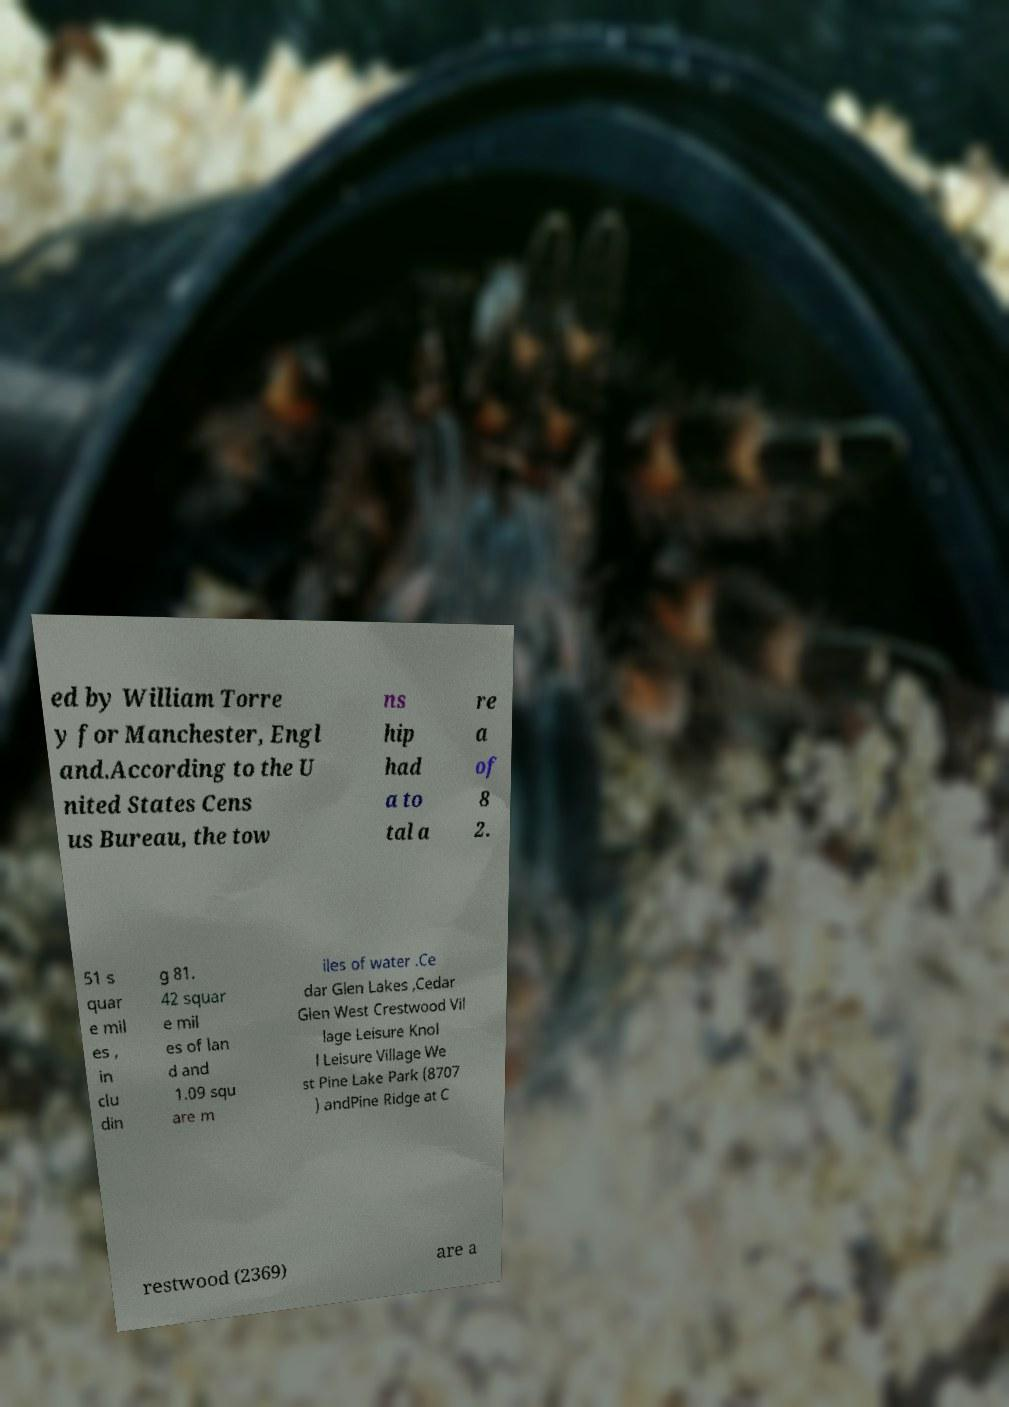I need the written content from this picture converted into text. Can you do that? ed by William Torre y for Manchester, Engl and.According to the U nited States Cens us Bureau, the tow ns hip had a to tal a re a of 8 2. 51 s quar e mil es , in clu din g 81. 42 squar e mil es of lan d and 1.09 squ are m iles of water .Ce dar Glen Lakes ,Cedar Glen West Crestwood Vil lage Leisure Knol l Leisure Village We st Pine Lake Park (8707 ) andPine Ridge at C restwood (2369) are a 